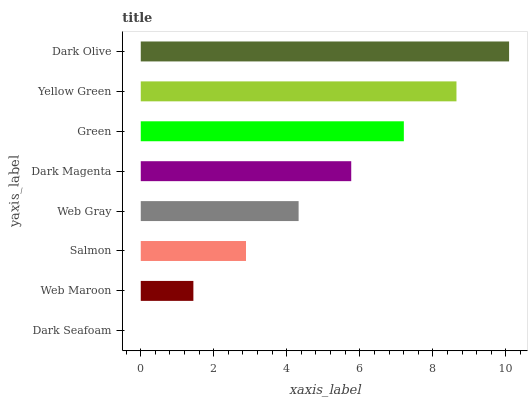Is Dark Seafoam the minimum?
Answer yes or no. Yes. Is Dark Olive the maximum?
Answer yes or no. Yes. Is Web Maroon the minimum?
Answer yes or no. No. Is Web Maroon the maximum?
Answer yes or no. No. Is Web Maroon greater than Dark Seafoam?
Answer yes or no. Yes. Is Dark Seafoam less than Web Maroon?
Answer yes or no. Yes. Is Dark Seafoam greater than Web Maroon?
Answer yes or no. No. Is Web Maroon less than Dark Seafoam?
Answer yes or no. No. Is Dark Magenta the high median?
Answer yes or no. Yes. Is Web Gray the low median?
Answer yes or no. Yes. Is Salmon the high median?
Answer yes or no. No. Is Green the low median?
Answer yes or no. No. 